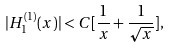<formula> <loc_0><loc_0><loc_500><loc_500>| H ^ { ( 1 ) } _ { 1 } ( x ) | < C [ \frac { 1 } { x } + \frac { 1 } { \sqrt { x } } ] ,</formula> 